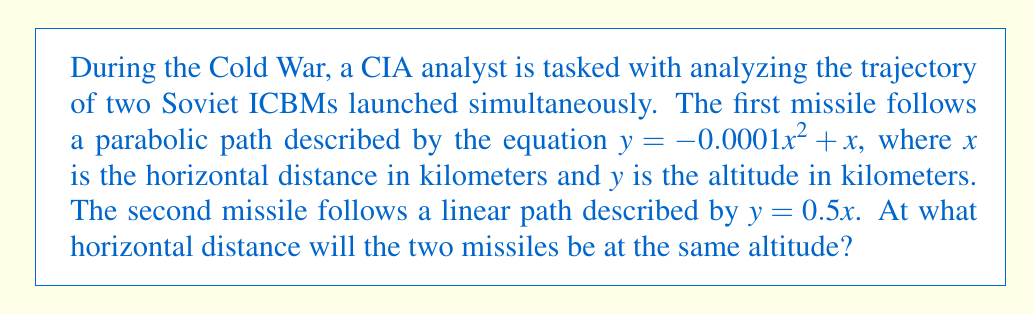Can you answer this question? To solve this problem, we need to find the point where the two equations intersect. This can be done by setting the equations equal to each other and solving for x.

1) Set the equations equal:
   $-0.0001x^2 + x = 0.5x$

2) Rearrange the equation:
   $-0.0001x^2 + 0.5x = 0$

3) Multiply all terms by 10000 to eliminate decimals:
   $-x^2 + 5000x = 0$

4) Factor out x:
   $x(-x + 5000) = 0$

5) Use the zero product property. x = 0 or -x + 5000 = 0

6) Solve for x:
   $x = 0$ or $x = 5000$

7) Since x represents distance, we can discard the negative solution. Therefore, the missiles will be at the same altitude when x = 5000 km.

8) To verify, we can plug this value back into both original equations:

   For the parabolic path: 
   $y = -0.0001(5000)^2 + 5000 = -0.0001(25000000) + 5000 = -2500 + 5000 = 2500$

   For the linear path:
   $y = 0.5(5000) = 2500$

   Both equations yield y = 2500 km, confirming our solution.
Answer: The two missiles will be at the same altitude at a horizontal distance of 5000 kilometers. 